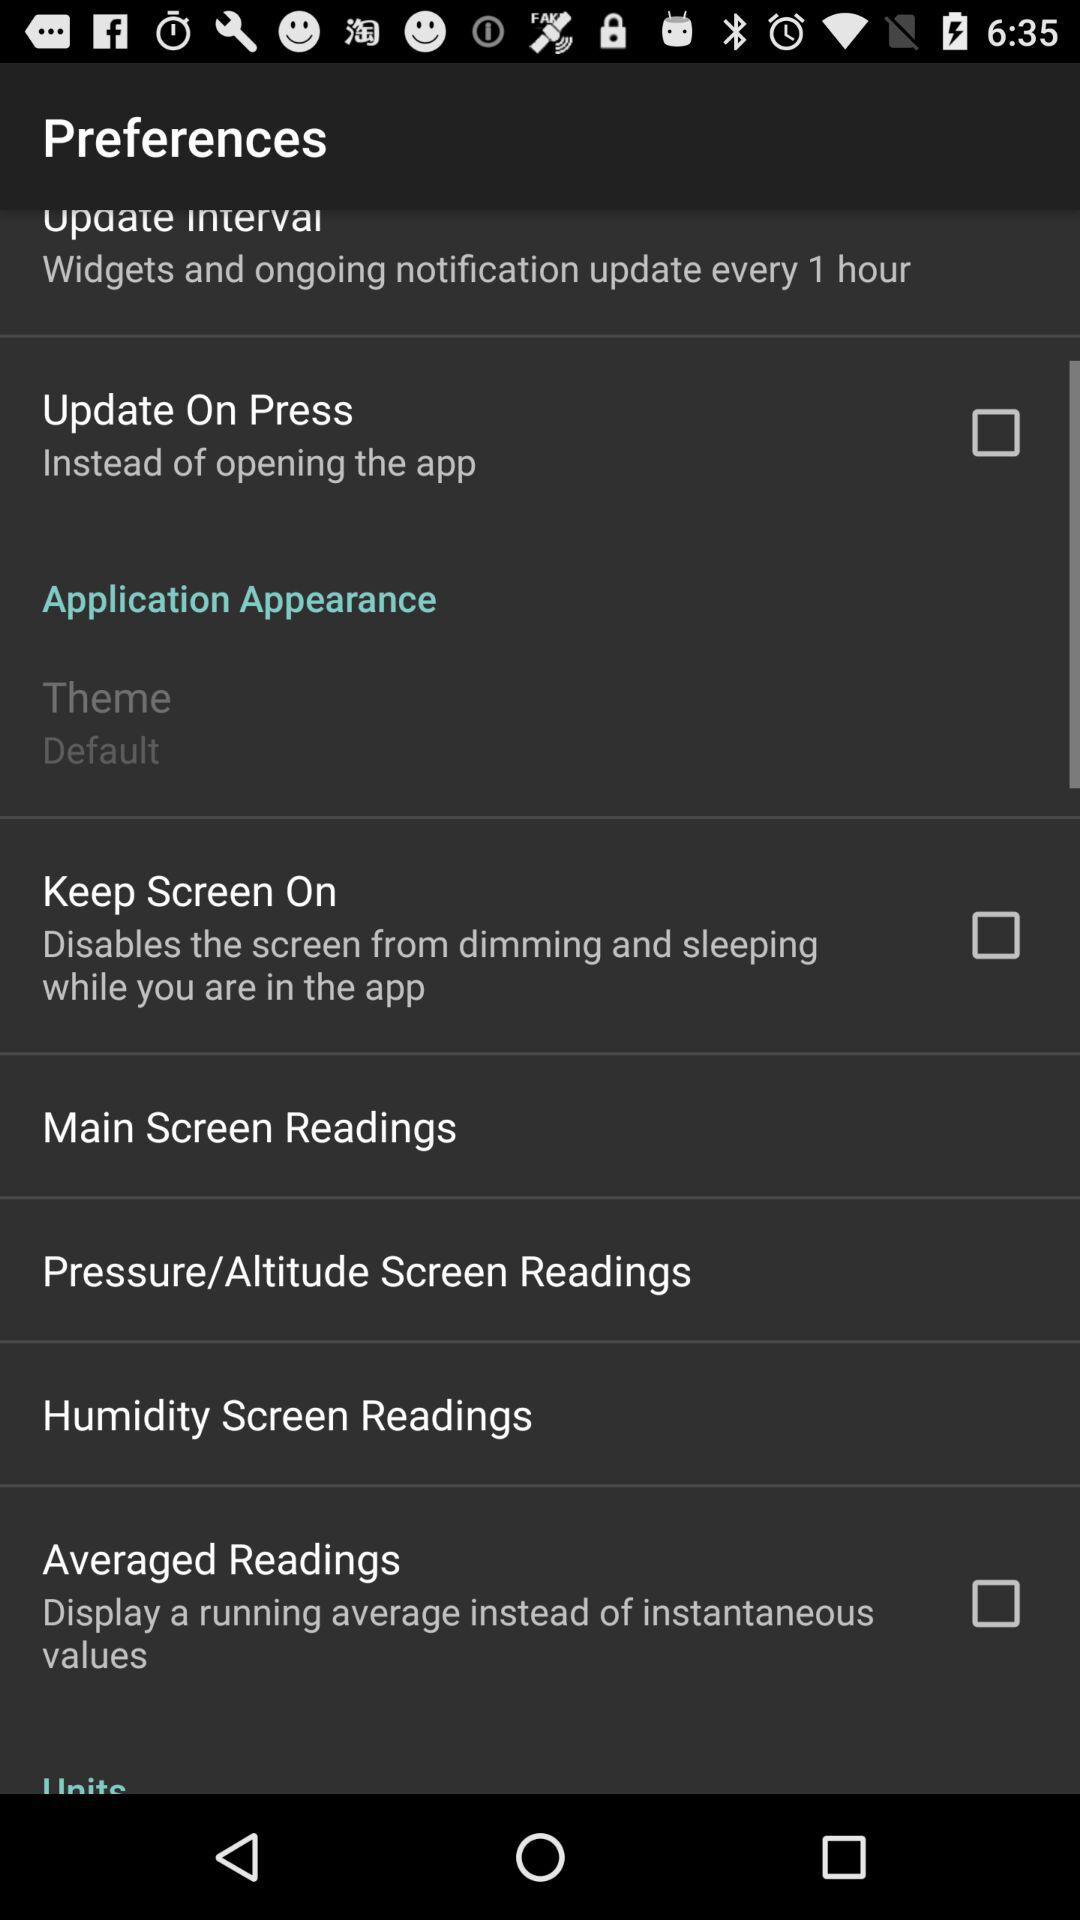In how many hours will the widgets and ongoing notification update happen? The widgets and ongoing notification updates will happen every 1 hour. 